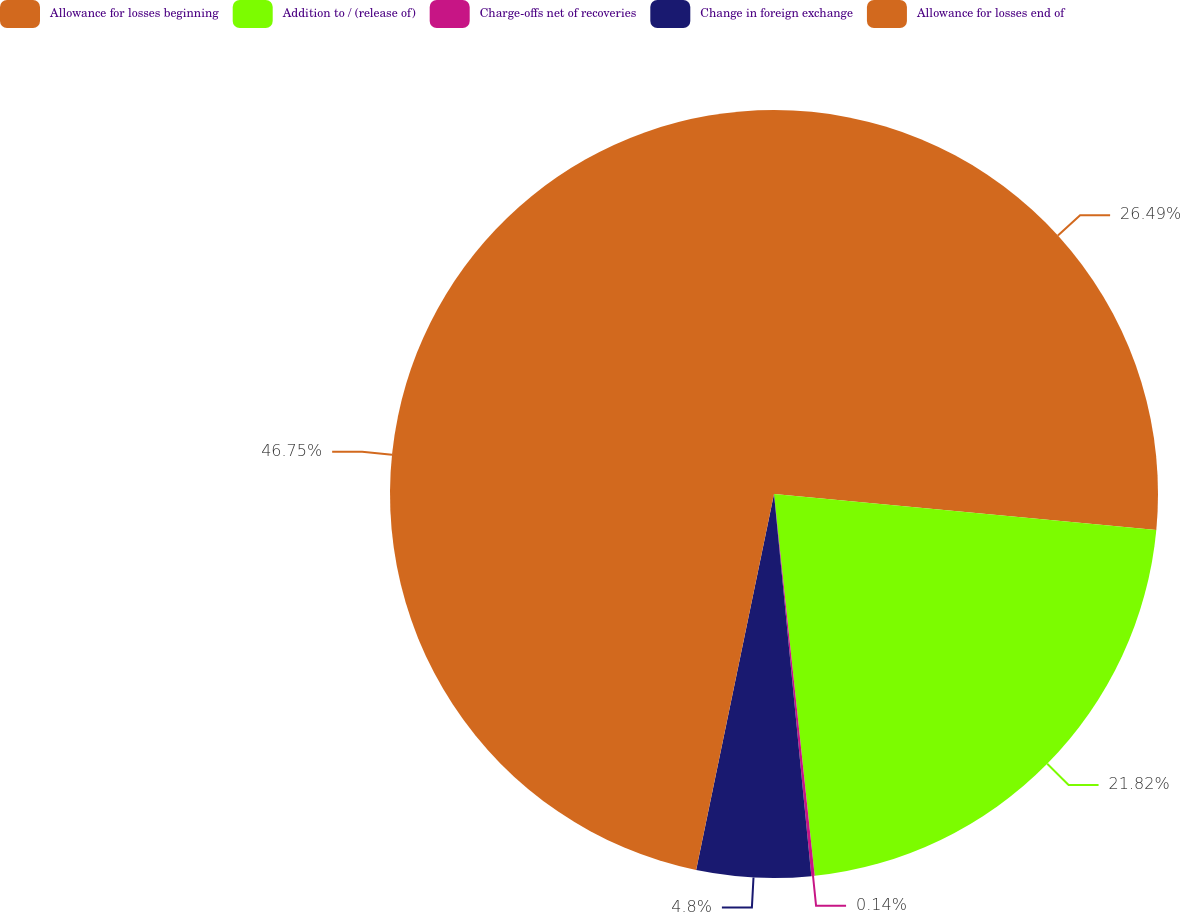Convert chart to OTSL. <chart><loc_0><loc_0><loc_500><loc_500><pie_chart><fcel>Allowance for losses beginning<fcel>Addition to / (release of)<fcel>Charge-offs net of recoveries<fcel>Change in foreign exchange<fcel>Allowance for losses end of<nl><fcel>26.49%<fcel>21.82%<fcel>0.14%<fcel>4.8%<fcel>46.75%<nl></chart> 